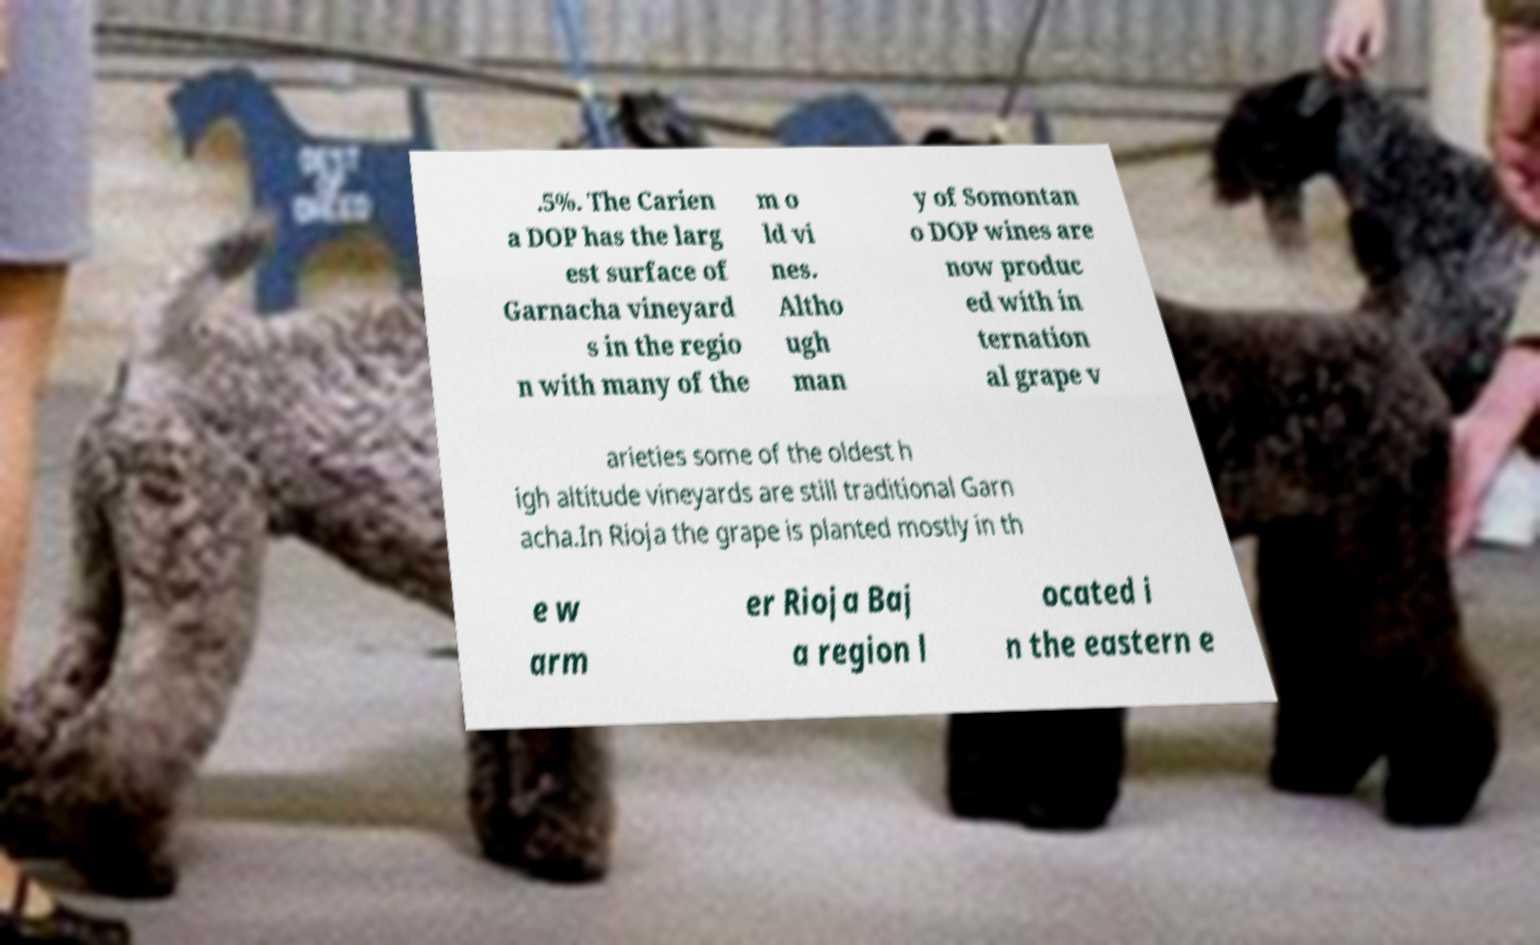What messages or text are displayed in this image? I need them in a readable, typed format. .5%. The Carien a DOP has the larg est surface of Garnacha vineyard s in the regio n with many of the m o ld vi nes. Altho ugh man y of Somontan o DOP wines are now produc ed with in ternation al grape v arieties some of the oldest h igh altitude vineyards are still traditional Garn acha.In Rioja the grape is planted mostly in th e w arm er Rioja Baj a region l ocated i n the eastern e 